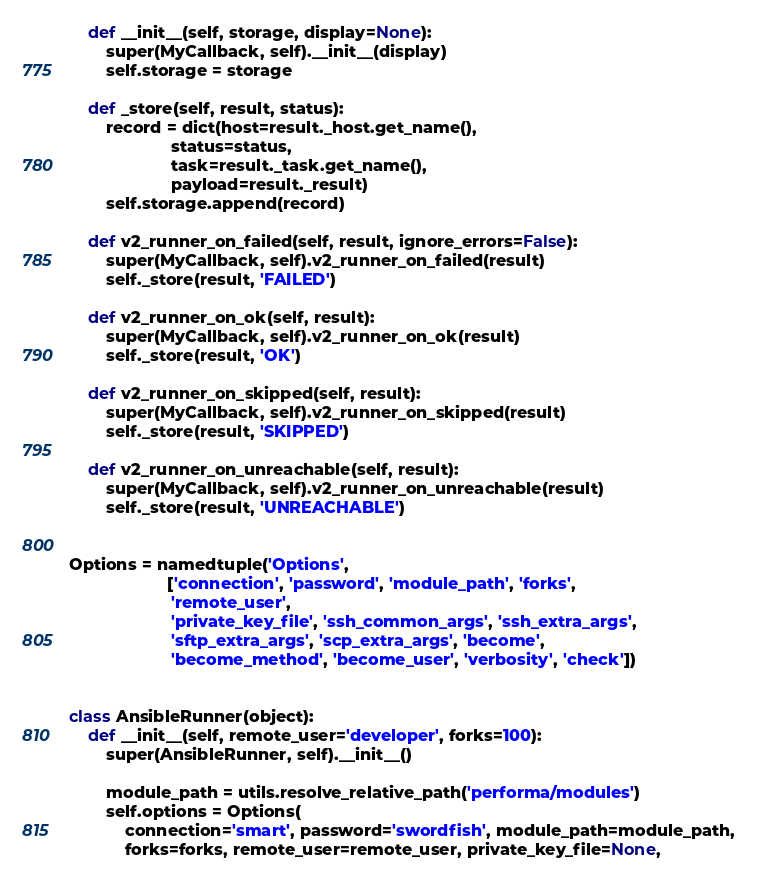Convert code to text. <code><loc_0><loc_0><loc_500><loc_500><_Python_>
    def __init__(self, storage, display=None):
        super(MyCallback, self).__init__(display)
        self.storage = storage

    def _store(self, result, status):
        record = dict(host=result._host.get_name(),
                      status=status,
                      task=result._task.get_name(),
                      payload=result._result)
        self.storage.append(record)

    def v2_runner_on_failed(self, result, ignore_errors=False):
        super(MyCallback, self).v2_runner_on_failed(result)
        self._store(result, 'FAILED')

    def v2_runner_on_ok(self, result):
        super(MyCallback, self).v2_runner_on_ok(result)
        self._store(result, 'OK')

    def v2_runner_on_skipped(self, result):
        super(MyCallback, self).v2_runner_on_skipped(result)
        self._store(result, 'SKIPPED')

    def v2_runner_on_unreachable(self, result):
        super(MyCallback, self).v2_runner_on_unreachable(result)
        self._store(result, 'UNREACHABLE')


Options = namedtuple('Options',
                     ['connection', 'password', 'module_path', 'forks',
                      'remote_user',
                      'private_key_file', 'ssh_common_args', 'ssh_extra_args',
                      'sftp_extra_args', 'scp_extra_args', 'become',
                      'become_method', 'become_user', 'verbosity', 'check'])


class AnsibleRunner(object):
    def __init__(self, remote_user='developer', forks=100):
        super(AnsibleRunner, self).__init__()

        module_path = utils.resolve_relative_path('performa/modules')
        self.options = Options(
            connection='smart', password='swordfish', module_path=module_path,
            forks=forks, remote_user=remote_user, private_key_file=None,</code> 